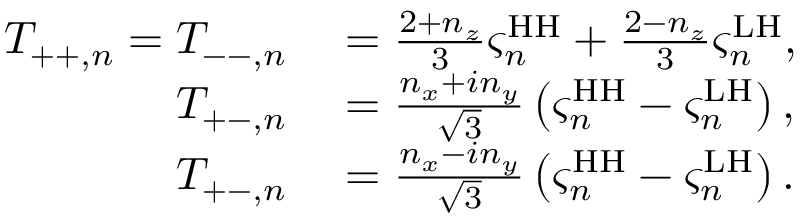Convert formula to latex. <formula><loc_0><loc_0><loc_500><loc_500>\begin{array} { r l } { T _ { + + , n } = T _ { - - , n } } & = \frac { 2 + n _ { z } } { 3 } \varsigma _ { n } ^ { H H } + \frac { 2 - n _ { z } } { 3 } \varsigma _ { n } ^ { L H } , } \\ { T _ { + - , n } } & = \frac { n _ { x } + i n _ { y } } { \sqrt { 3 } } \left ( \varsigma _ { n } ^ { H H } - \varsigma _ { n } ^ { L H } \right ) , } \\ { T _ { + - , n } } & = \frac { n _ { x } - i n _ { y } } { \sqrt { 3 } } \left ( \varsigma _ { n } ^ { H H } - \varsigma _ { n } ^ { L H } \right ) . } \end{array}</formula> 